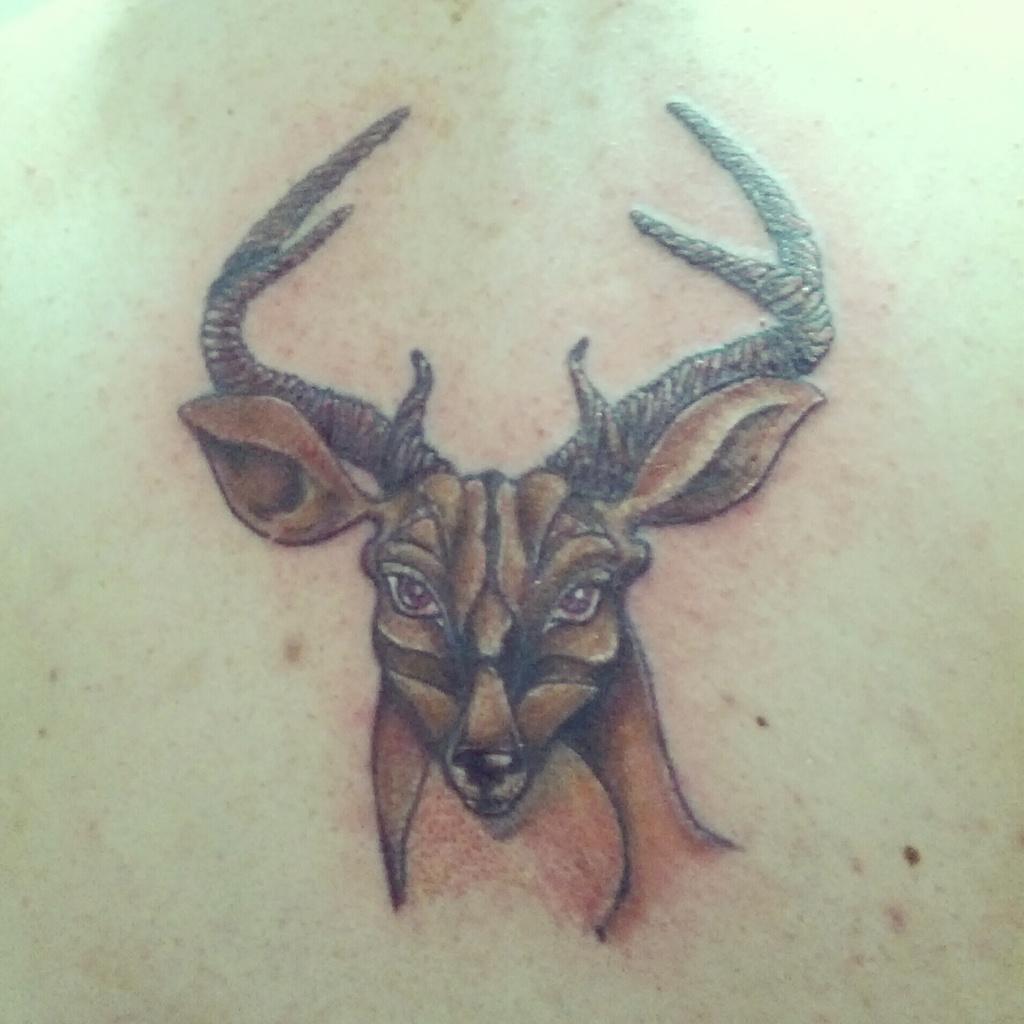Describe this image in one or two sentences. In this picture we can see and drawing photo of the brown deer in the image. 